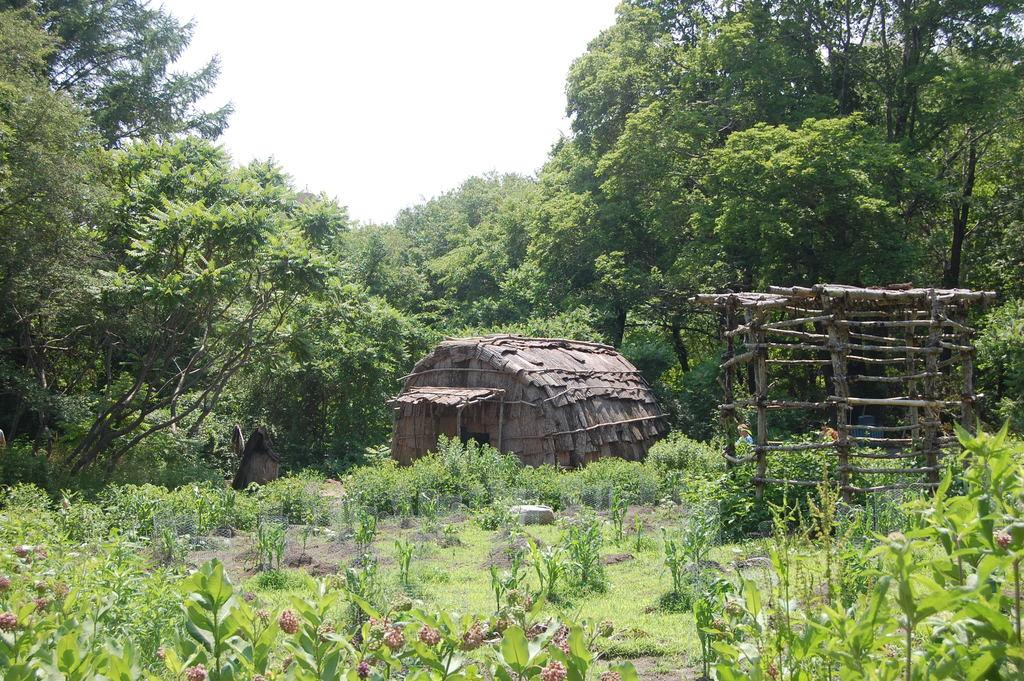What type of living organisms can be seen in the image? Plants can be seen in the image. What type of structure is present in the image? There is a hut and a wooden tent in the image. What can be seen in the background of the image? Trees and the sky are visible in the background of the image. What type of glass can be seen hanging from the trees in the image? There is no glass present in the image; it only features plants, a hut, a wooden tent, trees, and the sky in the background. 